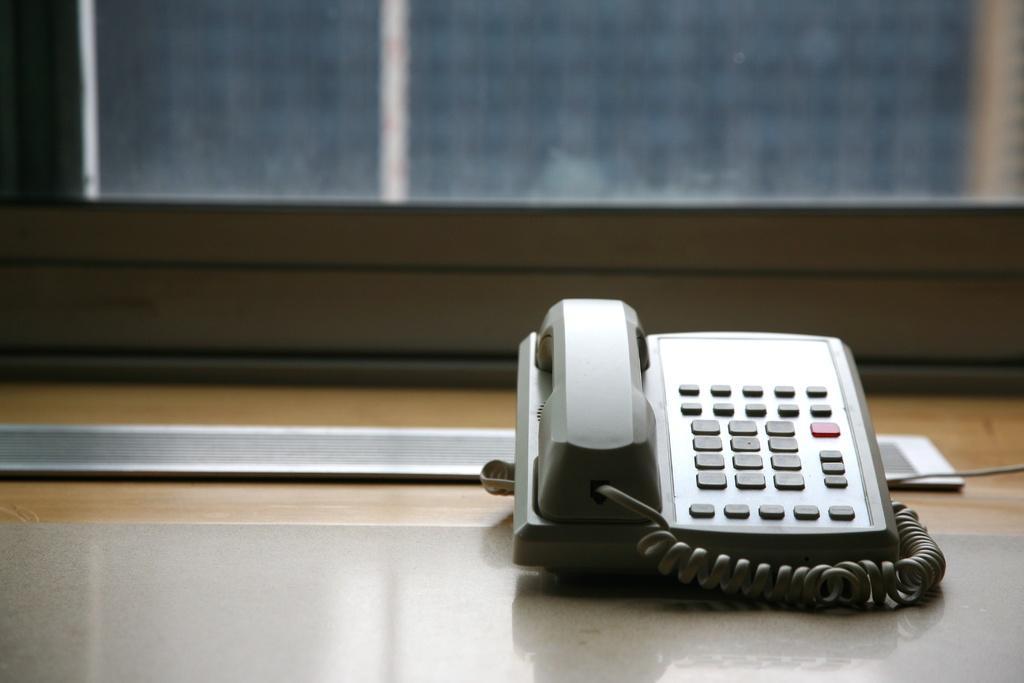In one or two sentences, can you explain what this image depicts? In this image, we can see a telephone with receiver, buttons and wire on the surface. At the top of the image, there is a glass object. In the middle of the picture, we can see wooden and metal objects. 